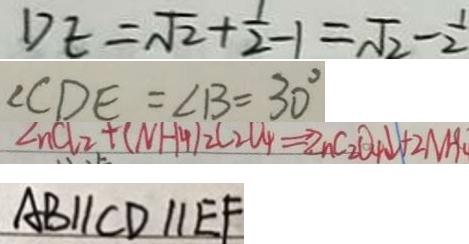Convert formula to latex. <formula><loc_0><loc_0><loc_500><loc_500>D E = \sqrt { 2 } + \frac { 1 } { 2 } - 1 = \sqrt { 2 } - \frac { 1 } { 2 } 
 \angle C D E = \angle B = 3 0 ^ { \circ } 
 \angle n C l _ { 2 } + ( N H _ { 4 } ) _ { 2 } C _ { 2 } O _ { 4 } \Rightarrow Z n C _ { 2 } O _ { 4 } \downarrow + 2 N H 
 A B / / C D / / E F</formula> 